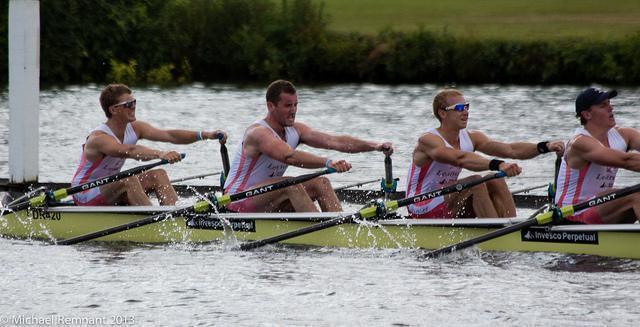Who are these people to each other?
Indicate the correct response and explain using: 'Answer: answer
Rationale: rationale.'
Options: Allies, teammates, relatives, enemies. Answer: teammates.
Rationale: The people are teammates. 